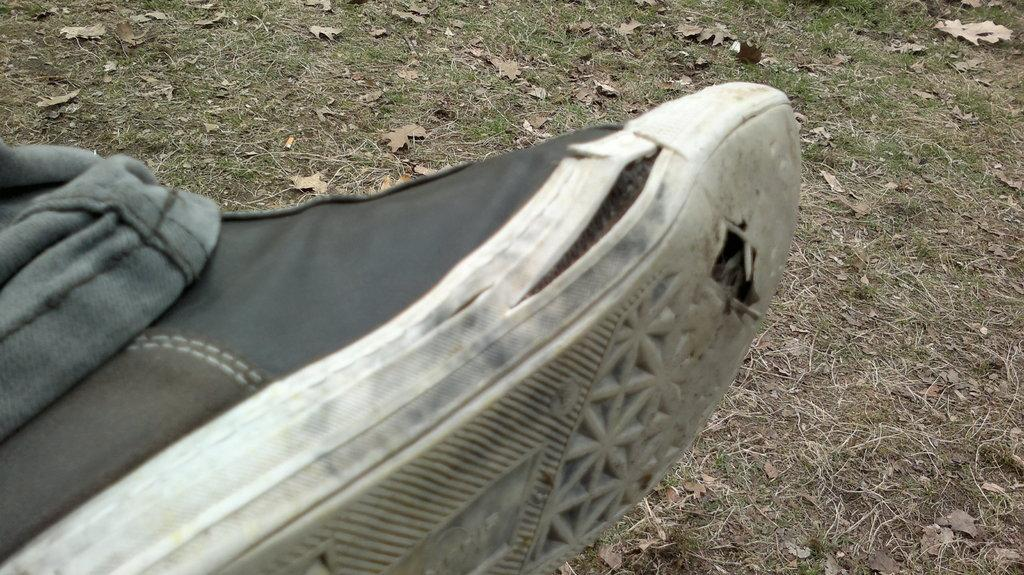What part of the body is visible in the image? There is a person's leg in the image. On which side of the image is the leg located? The leg is on the left side of the image. What is the leg wearing? The leg is wearing a shoe. How many icicles are hanging from the leg in the image? There are no icicles present in the image; it only shows a person's leg wearing a shoe. What type of frog can be seen sitting on the crate in the image? There is no crate or frog present in the image; it only shows a person's leg wearing a shoe. 